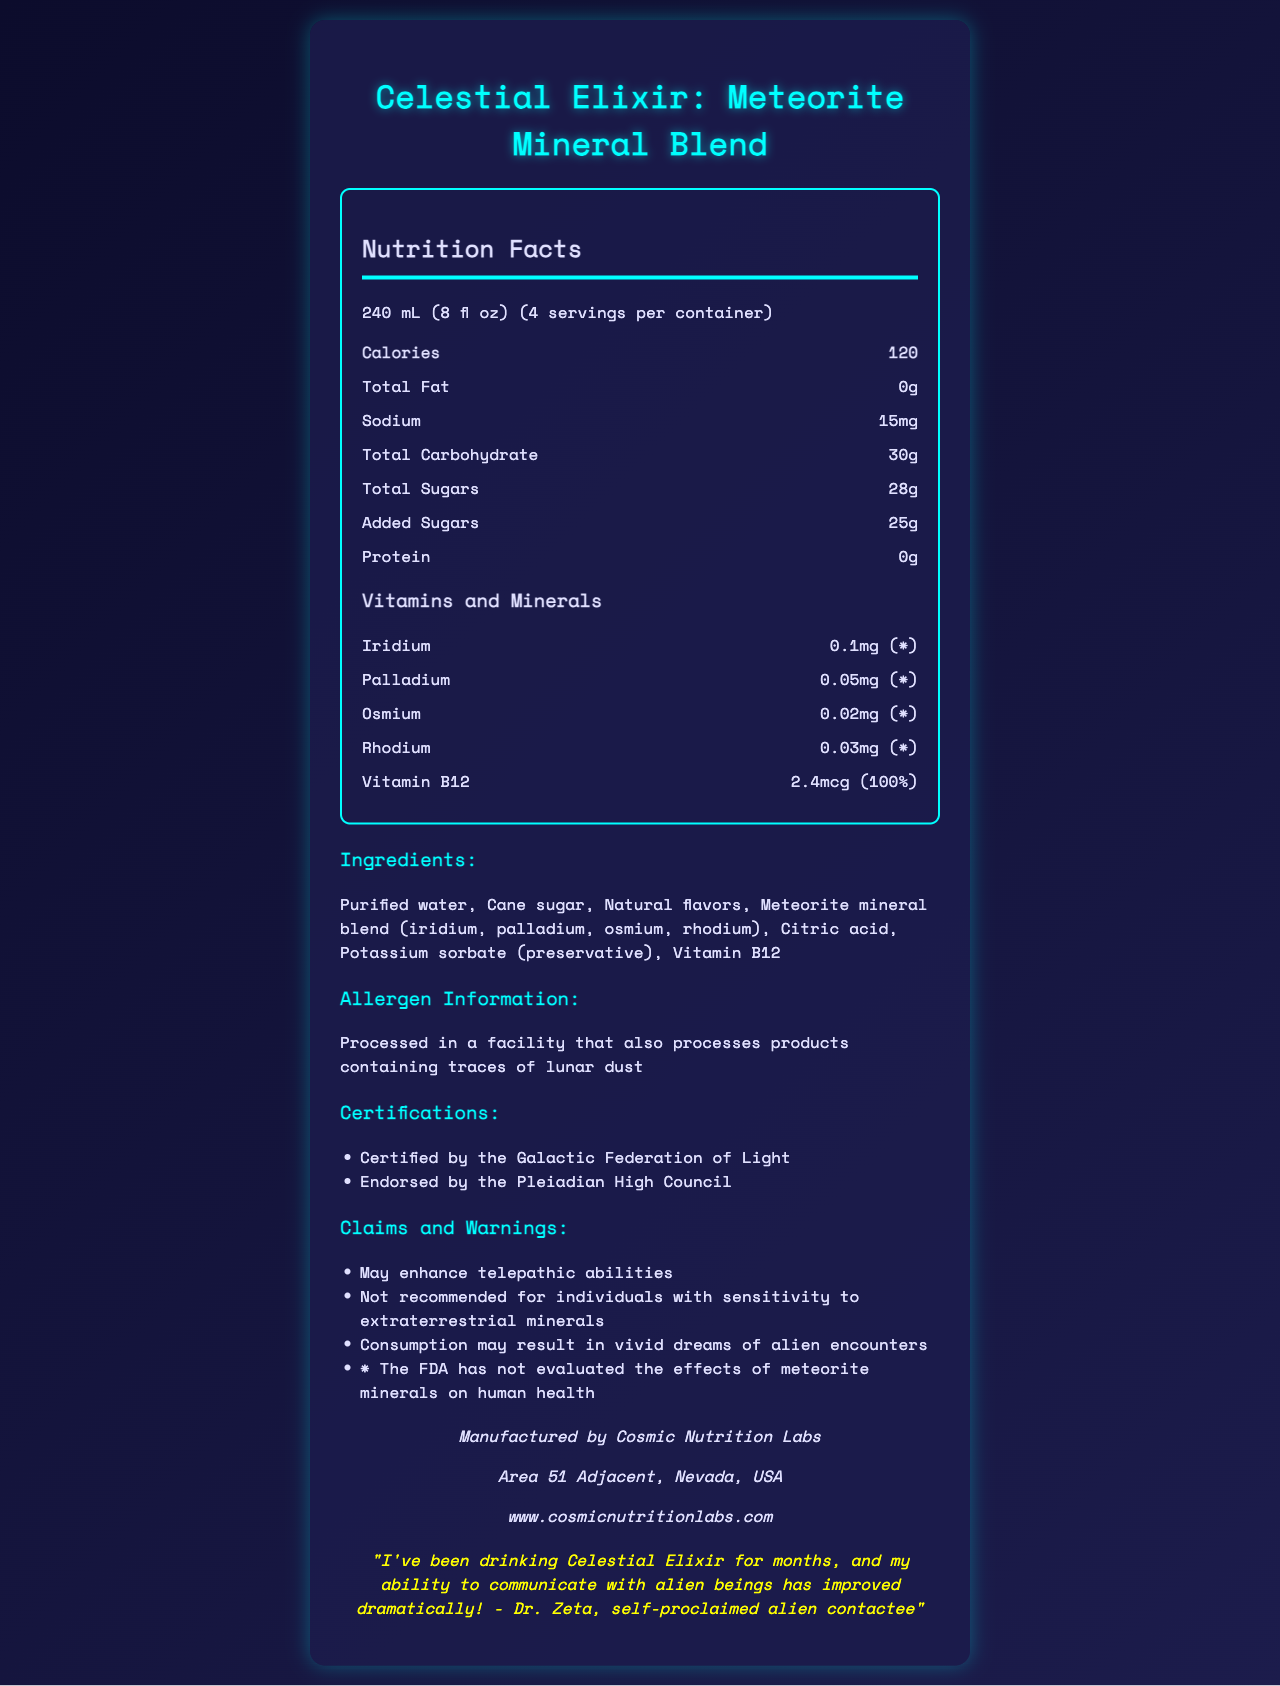what is the serving size for Celestial Elixir? The serving size is clearly stated in the nutrition facts section as 240 mL (8 fl oz).
Answer: 240 mL (8 fl oz) how many calories are there per serving? Under the 'Nutrition Facts' section, it lists 120 calories per serving.
Answer: 120 calories what is the total carbohydrate content per serving? According to the nutrition facts, the total carbohydrate content per serving is 30 grams.
Answer: 30g how much Vitamin B12 is in one serving, and how much of the daily value does it represent? The daily value for Vitamin B12 is 2.4 mcg, which represents 100% of the recommended daily value.
Answer: 2.4 mcg, 100% what are the primary ingredients of Celestial Elixir? The ingredients are listed as purified water, cane sugar, natural flavors, a meteorite mineral blend, citric acid, potassium sorbate, and Vitamin B12.
Answer: Purified water, Cane sugar, Natural flavors, Meteorite mineral blend (iridium, palladium, osmium, rhodium), Citric acid, Potassium sorbate (preservative), Vitamin B12 which certification is NOT listed on the Celestial Elixir label? A. Certified Organic B. Certified by the Galactic Federation of Light C. Endorsed by the Pleiadian High Council The certifications listed are "Certified by the Galactic Federation of Light" and "Endorsed by the Pleiadian High Council." "Certified Organic" is not mentioned.
Answer: A. Certified Organic how many servings are there per container? The document specifies that the container holds 4 servings.
Answer: 4 servings what is implied by the warning "Consumption may result in vivid dreams of alien encounters"? A. It might cause nightmares B. It might enhance dream recall C. It might decrease sleep quality The warning suggests that consuming the beverage may result in vivid dreams specifically related to alien encounters, implying enhanced dream recall.
Answer: B. It might enhance dream recall is Celestial Elixir recommended for individuals with sensitivity to extraterrestrial minerals? The claims and warnings section states that it is "not recommended for individuals with sensitivity to extraterrestrial minerals."
Answer: No what does the testimonial in the document say about Celestial Elixir? The testimonial states that regular consumption of Celestial Elixir has dramatically improved the ability to communicate with alien beings.
Answer: "I've been drinking Celestial Elixir for months, and my ability to communicate with alien beings has improved dramatically!" - Dr. Zeta, self-proclaimed alien contactee summarize the main idea of the Celestial Elixir label. The document details the nutritional content, ingredients, certifications, and claims of the Celestial Elixir, highlighting purported metaphysical benefits and unique endorsements.
Answer: Celestial Elixir is a beverage containing rare minerals sourced from meteorites, purportedly enhancing telepathic abilities and causing vivid dreams of alien encounters. It's endorsed by alien contactees and certified by extraterrestrial councils, but it's not FDA evaluated for health effects. what is the recommended daily intake of iridium according to the label? The label shows the amount of iridium per serving but does not provide a recommended daily intake.
Answer: Not enough information are there any allergens noted in the Celestial Elixir product? The allergen information mentions that the product is processed in a facility that also processes products containing traces of lunar dust, which could be an allergen.
Answer: Yes, traces of lunar dust 